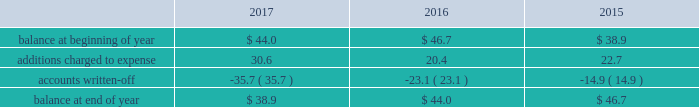Republic services , inc .
Notes to consolidated financial statements 2014 ( continued ) high quality financial institutions .
Such balances may be in excess of fdic insured limits .
To manage the related credit exposure , we continually monitor the credit worthiness of the financial institutions where we have deposits .
Concentrations of credit risk with respect to trade accounts receivable are limited due to the wide variety of customers and markets in which we provide services , as well as the dispersion of our operations across many geographic areas .
We provide services to small-container , large-container , municipal and residential , and energy services customers in the united states and puerto rico .
We perform ongoing credit evaluations of our customers , but generally do not require collateral to support customer receivables .
We establish an allowance for doubtful accounts based on various factors including the credit risk of specific customers , age of receivables outstanding , historical trends , economic conditions and other information .
Accounts receivable , net accounts receivable represent receivables from customers for collection , transfer , recycling , disposal , energy services and other services .
Our receivables are recorded when billed or when the related revenue is earned , if earlier , and represent claims against third parties that will be settled in cash .
The carrying value of our receivables , net of the allowance for doubtful accounts and customer credits , represents their estimated net realizable value .
Provisions for doubtful accounts are evaluated on a monthly basis and are recorded based on our historical collection experience , the age of the receivables , specific customer information and economic conditions .
We also review outstanding balances on an account-specific basis .
In general , reserves are provided for accounts receivable in excess of 90 days outstanding .
Past due receivable balances are written-off when our collection efforts have been unsuccessful in collecting amounts due .
The table reflects the activity in our allowance for doubtful accounts for the years ended december 31: .
Restricted cash and marketable securities as of december 31 , 2017 , we had $ 141.1 million of restricted cash and marketable securities of which $ 71.4 million supports our insurance programs for workers 2019 compensation , commercial general liability , and commercial auto liability .
Additionally , we obtain funds through the issuance of tax-exempt bonds for the purpose of financing qualifying expenditures at our landfills , transfer stations , collection and recycling centers .
The funds are deposited directly into trust accounts by the bonding authorities at the time of issuance .
As the use of these funds is contractually restricted , and we do not have the ability to use these funds for general operating purposes , they are classified as restricted cash and marketable securities in our consolidated balance sheets .
In the normal course of business , we may be required to provide financial assurance to governmental agencies and a variety of other entities in connection with municipal residential collection contracts , closure or post- closure of landfills , environmental remediation , environmental permits , and business licenses and permits as a financial guarantee of our performance .
At several of our landfills , we satisfy financial assurance requirements by depositing cash into restricted trust funds or escrow accounts .
Property and equipment we record property and equipment at cost .
Expenditures for major additions and improvements to facilities are capitalized , while maintenance and repairs are charged to expense as incurred .
When property is retired or .
As of december 31 , 2017 what was the ratio of restricted cash and marketable securities for the supports our insurance programs for workers 2019 compensation , commercial general liability , and commercial auto liability to the total restricted cash and marketable securities? 
Rationale: the percent of the amount set aside from the total restricted cash and marketable securities to the to the total restricted cash and marketable securities was 50.6%
Computations: (71.4 / 141.1)
Answer: 0.50602. 